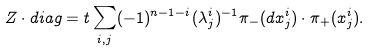Convert formula to latex. <formula><loc_0><loc_0><loc_500><loc_500>Z \cdot d i a g = t \sum _ { i , j } ( - 1 ) ^ { n - 1 - i } ( \lambda ^ { i } _ { j } ) ^ { - 1 } \pi _ { - } ( d x ^ { i } _ { j } ) \cdot \pi _ { + } ( x ^ { i } _ { j } ) .</formula> 